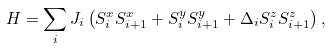<formula> <loc_0><loc_0><loc_500><loc_500>H = \sum _ { i } J _ { i } \left ( S _ { i } ^ { x } S _ { i + 1 } ^ { x } + S _ { i } ^ { y } S _ { i + 1 } ^ { y } + \Delta _ { i } S _ { i } ^ { z } S _ { i + 1 } ^ { z } \right ) ,</formula> 